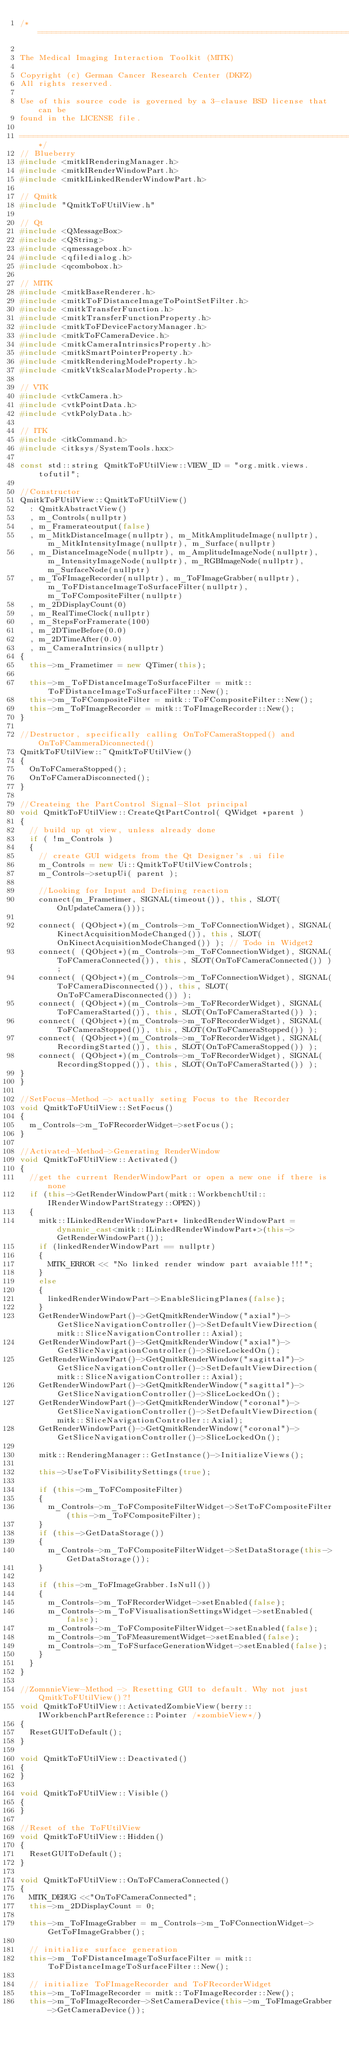Convert code to text. <code><loc_0><loc_0><loc_500><loc_500><_C++_>/*============================================================================

The Medical Imaging Interaction Toolkit (MITK)

Copyright (c) German Cancer Research Center (DKFZ)
All rights reserved.

Use of this source code is governed by a 3-clause BSD license that can be
found in the LICENSE file.

============================================================================*/
// Blueberry
#include <mitkIRenderingManager.h>
#include <mitkIRenderWindowPart.h>
#include <mitkILinkedRenderWindowPart.h>

// Qmitk
#include "QmitkToFUtilView.h"

// Qt
#include <QMessageBox>
#include <QString>
#include <qmessagebox.h>
#include <qfiledialog.h>
#include <qcombobox.h>

// MITK
#include <mitkBaseRenderer.h>
#include <mitkToFDistanceImageToPointSetFilter.h>
#include <mitkTransferFunction.h>
#include <mitkTransferFunctionProperty.h>
#include <mitkToFDeviceFactoryManager.h>
#include <mitkToFCameraDevice.h>
#include <mitkCameraIntrinsicsProperty.h>
#include <mitkSmartPointerProperty.h>
#include <mitkRenderingModeProperty.h>
#include <mitkVtkScalarModeProperty.h>

// VTK
#include <vtkCamera.h>
#include <vtkPointData.h>
#include <vtkPolyData.h>

// ITK
#include <itkCommand.h>
#include <itksys/SystemTools.hxx>

const std::string QmitkToFUtilView::VIEW_ID = "org.mitk.views.tofutil";

//Constructor
QmitkToFUtilView::QmitkToFUtilView()
  : QmitkAbstractView()
  , m_Controls(nullptr)
  , m_Framerateoutput(false)
  , m_MitkDistanceImage(nullptr), m_MitkAmplitudeImage(nullptr), m_MitkIntensityImage(nullptr), m_Surface(nullptr)
  , m_DistanceImageNode(nullptr), m_AmplitudeImageNode(nullptr), m_IntensityImageNode(nullptr), m_RGBImageNode(nullptr), m_SurfaceNode(nullptr)
  , m_ToFImageRecorder(nullptr), m_ToFImageGrabber(nullptr), m_ToFDistanceImageToSurfaceFilter(nullptr), m_ToFCompositeFilter(nullptr)
  , m_2DDisplayCount(0)
  , m_RealTimeClock(nullptr)
  , m_StepsForFramerate(100)
  , m_2DTimeBefore(0.0)
  , m_2DTimeAfter(0.0)
  , m_CameraIntrinsics(nullptr)
{
  this->m_Frametimer = new QTimer(this);

  this->m_ToFDistanceImageToSurfaceFilter = mitk::ToFDistanceImageToSurfaceFilter::New();
  this->m_ToFCompositeFilter = mitk::ToFCompositeFilter::New();
  this->m_ToFImageRecorder = mitk::ToFImageRecorder::New();
}

//Destructor, specifically calling OnToFCameraStopped() and OnToFCammeraDiconnected()
QmitkToFUtilView::~QmitkToFUtilView()
{
  OnToFCameraStopped();
  OnToFCameraDisconnected();
}

//Createing the PartControl Signal-Slot principal
void QmitkToFUtilView::CreateQtPartControl( QWidget *parent )
{
  // build up qt view, unless already done
  if ( !m_Controls )
  {
    // create GUI widgets from the Qt Designer's .ui file
    m_Controls = new Ui::QmitkToFUtilViewControls;
    m_Controls->setupUi( parent );

    //Looking for Input and Defining reaction
    connect(m_Frametimer, SIGNAL(timeout()), this, SLOT(OnUpdateCamera()));

    connect( (QObject*)(m_Controls->m_ToFConnectionWidget), SIGNAL(KinectAcquisitionModeChanged()), this, SLOT(OnKinectAcquisitionModeChanged()) ); // Todo in Widget2
    connect( (QObject*)(m_Controls->m_ToFConnectionWidget), SIGNAL(ToFCameraConnected()), this, SLOT(OnToFCameraConnected()) );
    connect( (QObject*)(m_Controls->m_ToFConnectionWidget), SIGNAL(ToFCameraDisconnected()), this, SLOT(OnToFCameraDisconnected()) );
    connect( (QObject*)(m_Controls->m_ToFRecorderWidget), SIGNAL(ToFCameraStarted()), this, SLOT(OnToFCameraStarted()) );
    connect( (QObject*)(m_Controls->m_ToFRecorderWidget), SIGNAL(ToFCameraStopped()), this, SLOT(OnToFCameraStopped()) );
    connect( (QObject*)(m_Controls->m_ToFRecorderWidget), SIGNAL(RecordingStarted()), this, SLOT(OnToFCameraStopped()) );
    connect( (QObject*)(m_Controls->m_ToFRecorderWidget), SIGNAL(RecordingStopped()), this, SLOT(OnToFCameraStarted()) );
}
}

//SetFocus-Method -> actually seting Focus to the Recorder
void QmitkToFUtilView::SetFocus()
{
  m_Controls->m_ToFRecorderWidget->setFocus();
}

//Activated-Method->Generating RenderWindow
void QmitkToFUtilView::Activated()
{
  //get the current RenderWindowPart or open a new one if there is none
  if (this->GetRenderWindowPart(mitk::WorkbenchUtil::IRenderWindowPartStrategy::OPEN))
  {
    mitk::ILinkedRenderWindowPart* linkedRenderWindowPart = dynamic_cast<mitk::ILinkedRenderWindowPart*>(this->GetRenderWindowPart());
    if (linkedRenderWindowPart == nullptr)
    {
      MITK_ERROR << "No linked render window part avaiable!!!";
    }
    else
    {
      linkedRenderWindowPart->EnableSlicingPlanes(false);
    }
    GetRenderWindowPart()->GetQmitkRenderWindow("axial")->GetSliceNavigationController()->SetDefaultViewDirection(mitk::SliceNavigationController::Axial);
    GetRenderWindowPart()->GetQmitkRenderWindow("axial")->GetSliceNavigationController()->SliceLockedOn();
    GetRenderWindowPart()->GetQmitkRenderWindow("sagittal")->GetSliceNavigationController()->SetDefaultViewDirection(mitk::SliceNavigationController::Axial);
    GetRenderWindowPart()->GetQmitkRenderWindow("sagittal")->GetSliceNavigationController()->SliceLockedOn();
    GetRenderWindowPart()->GetQmitkRenderWindow("coronal")->GetSliceNavigationController()->SetDefaultViewDirection(mitk::SliceNavigationController::Axial);
    GetRenderWindowPart()->GetQmitkRenderWindow("coronal")->GetSliceNavigationController()->SliceLockedOn();

    mitk::RenderingManager::GetInstance()->InitializeViews();

    this->UseToFVisibilitySettings(true);

    if (this->m_ToFCompositeFilter)
    {
      m_Controls->m_ToFCompositeFilterWidget->SetToFCompositeFilter(this->m_ToFCompositeFilter);
    }
    if (this->GetDataStorage())
    {
      m_Controls->m_ToFCompositeFilterWidget->SetDataStorage(this->GetDataStorage());
    }

    if (this->m_ToFImageGrabber.IsNull())
    {
      m_Controls->m_ToFRecorderWidget->setEnabled(false);
      m_Controls->m_ToFVisualisationSettingsWidget->setEnabled(false);
      m_Controls->m_ToFCompositeFilterWidget->setEnabled(false);
      m_Controls->m_ToFMeasurementWidget->setEnabled(false);
      m_Controls->m_ToFSurfaceGenerationWidget->setEnabled(false);
    }
  }
}

//ZomnnieView-Method -> Resetting GUI to default. Why not just QmitkToFUtilView()?!
void QmitkToFUtilView::ActivatedZombieView(berry::IWorkbenchPartReference::Pointer /*zombieView*/)
{
  ResetGUIToDefault();
}

void QmitkToFUtilView::Deactivated()
{
}

void QmitkToFUtilView::Visible()
{
}

//Reset of the ToFUtilView
void QmitkToFUtilView::Hidden()
{
  ResetGUIToDefault();
}

void QmitkToFUtilView::OnToFCameraConnected()
{
  MITK_DEBUG <<"OnToFCameraConnected";
  this->m_2DDisplayCount = 0;

  this->m_ToFImageGrabber = m_Controls->m_ToFConnectionWidget->GetToFImageGrabber();

  // initialize surface generation
  this->m_ToFDistanceImageToSurfaceFilter = mitk::ToFDistanceImageToSurfaceFilter::New();

  // initialize ToFImageRecorder and ToFRecorderWidget
  this->m_ToFImageRecorder = mitk::ToFImageRecorder::New();
  this->m_ToFImageRecorder->SetCameraDevice(this->m_ToFImageGrabber->GetCameraDevice());</code> 